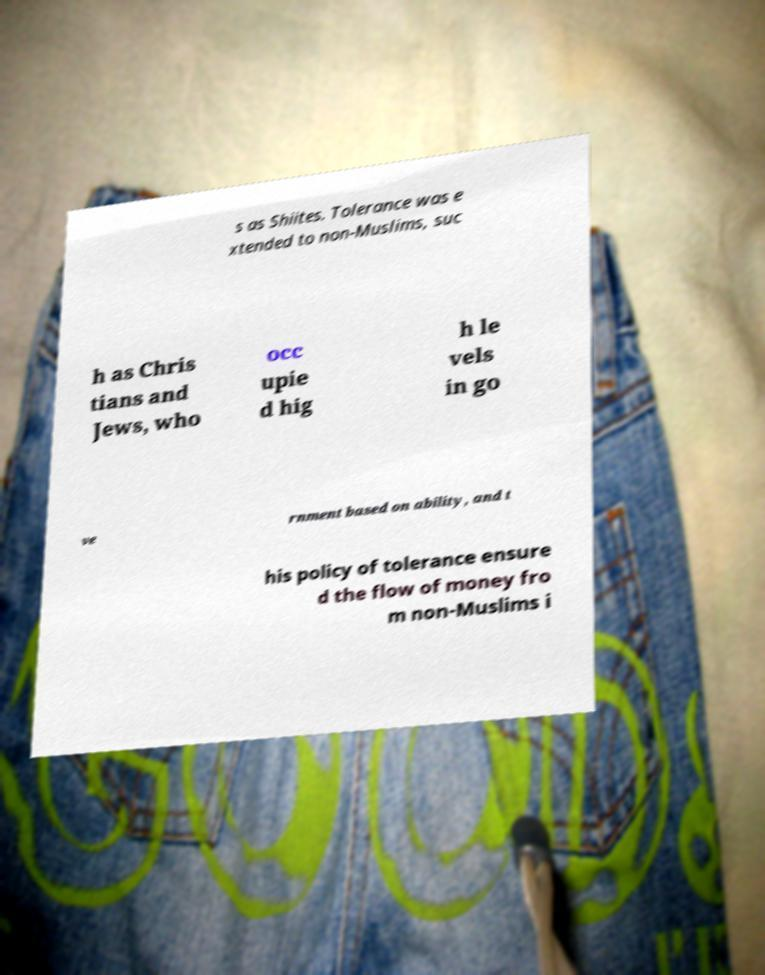Please identify and transcribe the text found in this image. s as Shiites. Tolerance was e xtended to non-Muslims, suc h as Chris tians and Jews, who occ upie d hig h le vels in go ve rnment based on ability, and t his policy of tolerance ensure d the flow of money fro m non-Muslims i 